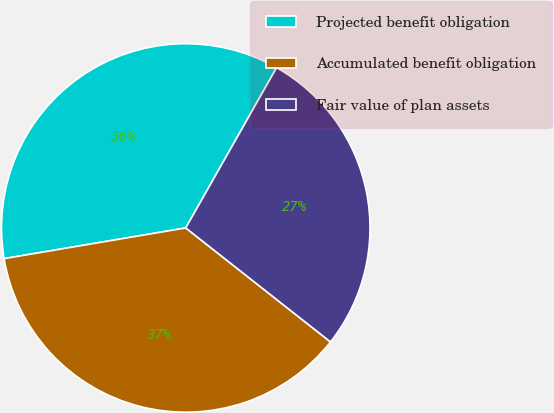<chart> <loc_0><loc_0><loc_500><loc_500><pie_chart><fcel>Projected benefit obligation<fcel>Accumulated benefit obligation<fcel>Fair value of plan assets<nl><fcel>35.87%<fcel>36.72%<fcel>27.41%<nl></chart> 